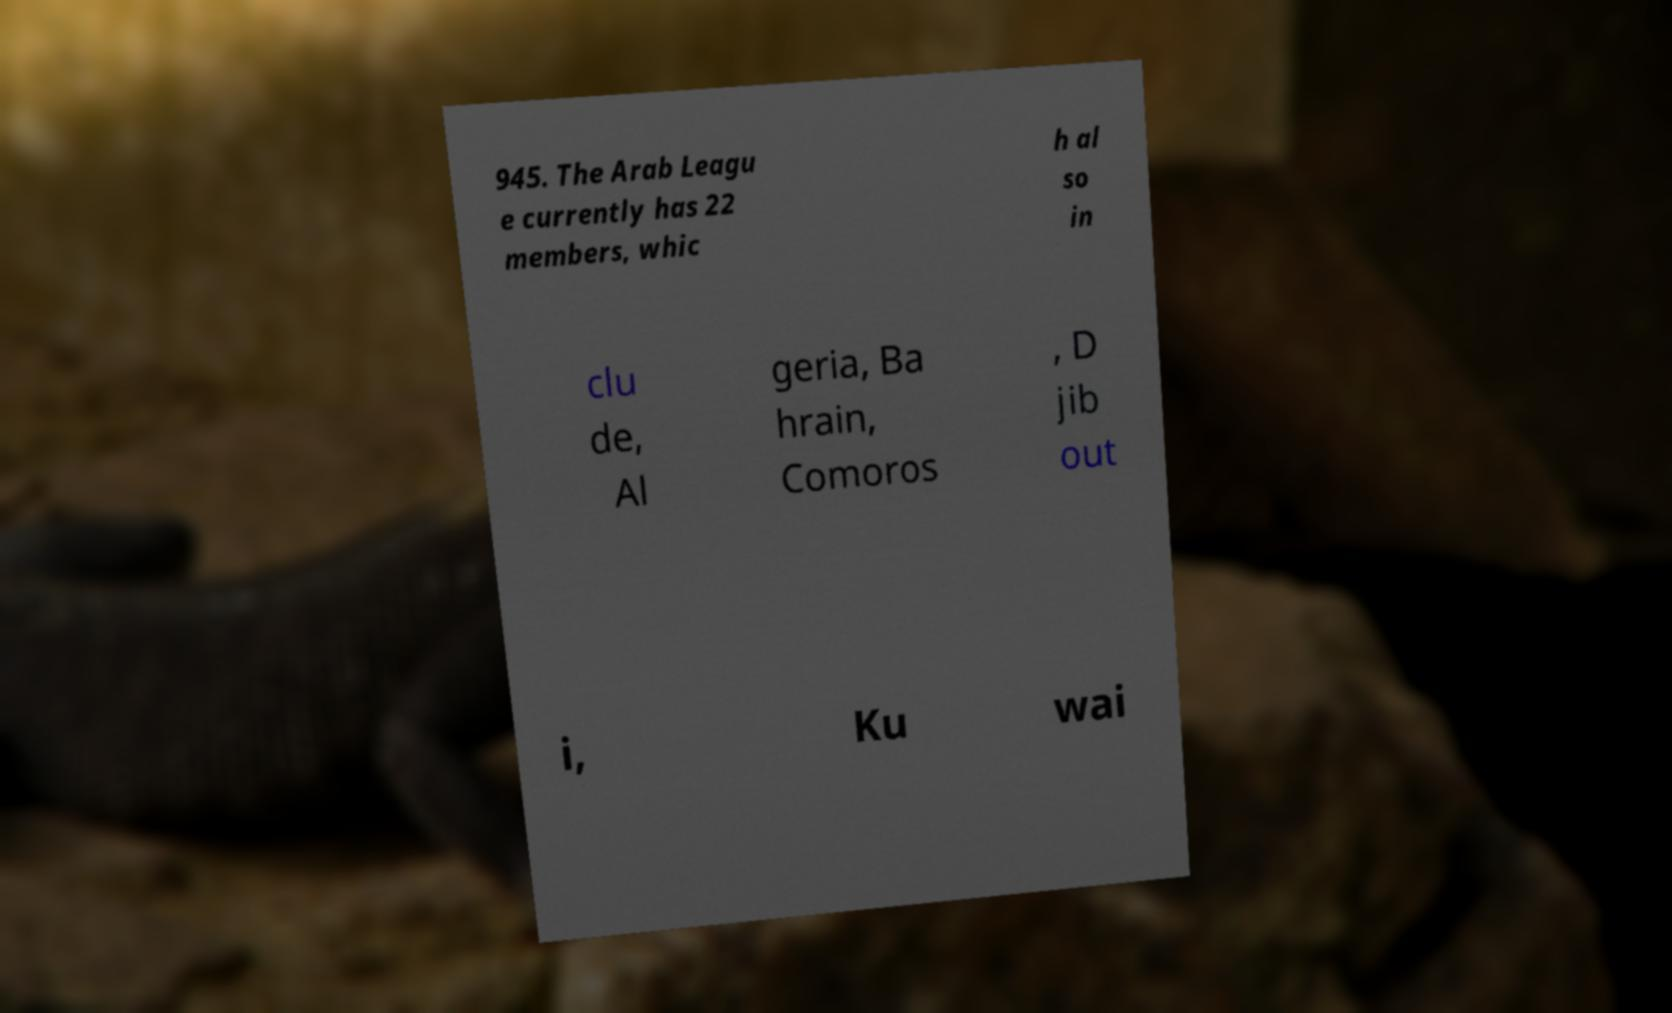Please identify and transcribe the text found in this image. 945. The Arab Leagu e currently has 22 members, whic h al so in clu de, Al geria, Ba hrain, Comoros , D jib out i, Ku wai 